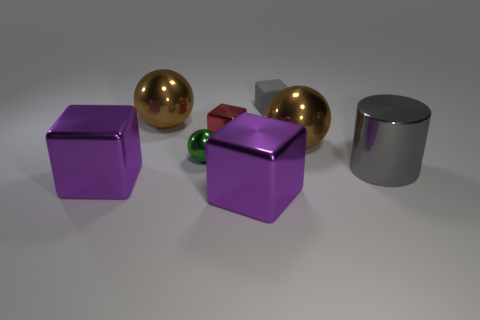Add 1 large objects. How many objects exist? 9 Subtract all cylinders. How many objects are left? 7 Add 2 gray blocks. How many gray blocks are left? 3 Add 5 red blocks. How many red blocks exist? 6 Subtract 0 yellow cylinders. How many objects are left? 8 Subtract all big gray things. Subtract all big gray cylinders. How many objects are left? 6 